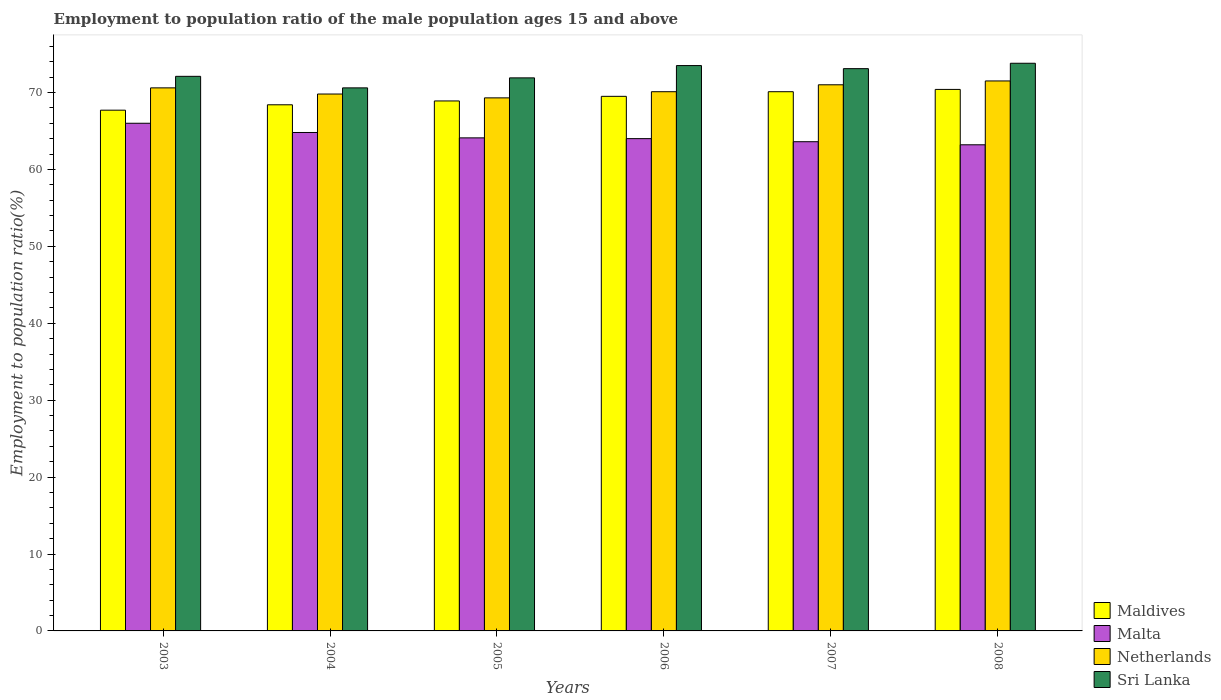How many groups of bars are there?
Your answer should be compact. 6. Are the number of bars on each tick of the X-axis equal?
Your answer should be very brief. Yes. How many bars are there on the 6th tick from the left?
Provide a succinct answer. 4. How many bars are there on the 5th tick from the right?
Offer a terse response. 4. What is the label of the 3rd group of bars from the left?
Offer a very short reply. 2005. In how many cases, is the number of bars for a given year not equal to the number of legend labels?
Make the answer very short. 0. What is the employment to population ratio in Netherlands in 2006?
Provide a succinct answer. 70.1. Across all years, what is the maximum employment to population ratio in Maldives?
Keep it short and to the point. 70.4. Across all years, what is the minimum employment to population ratio in Sri Lanka?
Give a very brief answer. 70.6. What is the total employment to population ratio in Netherlands in the graph?
Provide a short and direct response. 422.3. What is the difference between the employment to population ratio in Sri Lanka in 2003 and that in 2005?
Provide a succinct answer. 0.2. What is the difference between the employment to population ratio in Malta in 2008 and the employment to population ratio in Sri Lanka in 2005?
Your answer should be very brief. -8.7. What is the average employment to population ratio in Malta per year?
Make the answer very short. 64.28. In the year 2008, what is the difference between the employment to population ratio in Malta and employment to population ratio in Maldives?
Provide a succinct answer. -7.2. What is the ratio of the employment to population ratio in Malta in 2003 to that in 2007?
Keep it short and to the point. 1.04. Is the employment to population ratio in Maldives in 2005 less than that in 2006?
Provide a short and direct response. Yes. What is the difference between the highest and the second highest employment to population ratio in Maldives?
Offer a very short reply. 0.3. What is the difference between the highest and the lowest employment to population ratio in Malta?
Give a very brief answer. 2.8. What does the 4th bar from the left in 2003 represents?
Offer a terse response. Sri Lanka. What does the 4th bar from the right in 2007 represents?
Give a very brief answer. Maldives. How many years are there in the graph?
Your response must be concise. 6. Are the values on the major ticks of Y-axis written in scientific E-notation?
Your response must be concise. No. How many legend labels are there?
Keep it short and to the point. 4. How are the legend labels stacked?
Provide a succinct answer. Vertical. What is the title of the graph?
Provide a short and direct response. Employment to population ratio of the male population ages 15 and above. Does "Qatar" appear as one of the legend labels in the graph?
Offer a terse response. No. What is the Employment to population ratio(%) in Maldives in 2003?
Keep it short and to the point. 67.7. What is the Employment to population ratio(%) of Malta in 2003?
Give a very brief answer. 66. What is the Employment to population ratio(%) of Netherlands in 2003?
Ensure brevity in your answer.  70.6. What is the Employment to population ratio(%) in Sri Lanka in 2003?
Give a very brief answer. 72.1. What is the Employment to population ratio(%) of Maldives in 2004?
Provide a short and direct response. 68.4. What is the Employment to population ratio(%) in Malta in 2004?
Provide a short and direct response. 64.8. What is the Employment to population ratio(%) of Netherlands in 2004?
Offer a terse response. 69.8. What is the Employment to population ratio(%) in Sri Lanka in 2004?
Provide a succinct answer. 70.6. What is the Employment to population ratio(%) of Maldives in 2005?
Offer a very short reply. 68.9. What is the Employment to population ratio(%) of Malta in 2005?
Offer a very short reply. 64.1. What is the Employment to population ratio(%) in Netherlands in 2005?
Your response must be concise. 69.3. What is the Employment to population ratio(%) in Sri Lanka in 2005?
Keep it short and to the point. 71.9. What is the Employment to population ratio(%) in Maldives in 2006?
Keep it short and to the point. 69.5. What is the Employment to population ratio(%) in Netherlands in 2006?
Your response must be concise. 70.1. What is the Employment to population ratio(%) in Sri Lanka in 2006?
Keep it short and to the point. 73.5. What is the Employment to population ratio(%) in Maldives in 2007?
Offer a terse response. 70.1. What is the Employment to population ratio(%) in Malta in 2007?
Your response must be concise. 63.6. What is the Employment to population ratio(%) in Netherlands in 2007?
Your response must be concise. 71. What is the Employment to population ratio(%) in Sri Lanka in 2007?
Your answer should be very brief. 73.1. What is the Employment to population ratio(%) of Maldives in 2008?
Give a very brief answer. 70.4. What is the Employment to population ratio(%) in Malta in 2008?
Your answer should be very brief. 63.2. What is the Employment to population ratio(%) of Netherlands in 2008?
Provide a short and direct response. 71.5. What is the Employment to population ratio(%) in Sri Lanka in 2008?
Provide a short and direct response. 73.8. Across all years, what is the maximum Employment to population ratio(%) of Maldives?
Provide a short and direct response. 70.4. Across all years, what is the maximum Employment to population ratio(%) of Netherlands?
Offer a terse response. 71.5. Across all years, what is the maximum Employment to population ratio(%) in Sri Lanka?
Offer a very short reply. 73.8. Across all years, what is the minimum Employment to population ratio(%) of Maldives?
Offer a very short reply. 67.7. Across all years, what is the minimum Employment to population ratio(%) of Malta?
Your answer should be very brief. 63.2. Across all years, what is the minimum Employment to population ratio(%) of Netherlands?
Your answer should be very brief. 69.3. Across all years, what is the minimum Employment to population ratio(%) of Sri Lanka?
Offer a terse response. 70.6. What is the total Employment to population ratio(%) in Maldives in the graph?
Keep it short and to the point. 415. What is the total Employment to population ratio(%) in Malta in the graph?
Offer a terse response. 385.7. What is the total Employment to population ratio(%) in Netherlands in the graph?
Your response must be concise. 422.3. What is the total Employment to population ratio(%) of Sri Lanka in the graph?
Offer a terse response. 435. What is the difference between the Employment to population ratio(%) of Maldives in 2003 and that in 2004?
Your answer should be very brief. -0.7. What is the difference between the Employment to population ratio(%) of Malta in 2003 and that in 2004?
Provide a short and direct response. 1.2. What is the difference between the Employment to population ratio(%) of Netherlands in 2003 and that in 2004?
Offer a terse response. 0.8. What is the difference between the Employment to population ratio(%) in Sri Lanka in 2003 and that in 2004?
Offer a very short reply. 1.5. What is the difference between the Employment to population ratio(%) in Maldives in 2003 and that in 2005?
Your answer should be very brief. -1.2. What is the difference between the Employment to population ratio(%) in Netherlands in 2003 and that in 2005?
Offer a very short reply. 1.3. What is the difference between the Employment to population ratio(%) of Maldives in 2003 and that in 2006?
Offer a terse response. -1.8. What is the difference between the Employment to population ratio(%) of Netherlands in 2003 and that in 2007?
Offer a terse response. -0.4. What is the difference between the Employment to population ratio(%) of Sri Lanka in 2003 and that in 2007?
Give a very brief answer. -1. What is the difference between the Employment to population ratio(%) in Maldives in 2003 and that in 2008?
Offer a terse response. -2.7. What is the difference between the Employment to population ratio(%) in Malta in 2003 and that in 2008?
Make the answer very short. 2.8. What is the difference between the Employment to population ratio(%) of Netherlands in 2003 and that in 2008?
Give a very brief answer. -0.9. What is the difference between the Employment to population ratio(%) in Maldives in 2004 and that in 2005?
Keep it short and to the point. -0.5. What is the difference between the Employment to population ratio(%) in Malta in 2004 and that in 2005?
Offer a terse response. 0.7. What is the difference between the Employment to population ratio(%) in Maldives in 2004 and that in 2007?
Your answer should be compact. -1.7. What is the difference between the Employment to population ratio(%) in Malta in 2004 and that in 2007?
Offer a very short reply. 1.2. What is the difference between the Employment to population ratio(%) in Netherlands in 2004 and that in 2007?
Keep it short and to the point. -1.2. What is the difference between the Employment to population ratio(%) of Maldives in 2004 and that in 2008?
Ensure brevity in your answer.  -2. What is the difference between the Employment to population ratio(%) in Sri Lanka in 2004 and that in 2008?
Offer a terse response. -3.2. What is the difference between the Employment to population ratio(%) in Maldives in 2005 and that in 2006?
Offer a terse response. -0.6. What is the difference between the Employment to population ratio(%) of Netherlands in 2005 and that in 2006?
Give a very brief answer. -0.8. What is the difference between the Employment to population ratio(%) of Sri Lanka in 2005 and that in 2007?
Provide a short and direct response. -1.2. What is the difference between the Employment to population ratio(%) in Maldives in 2005 and that in 2008?
Provide a short and direct response. -1.5. What is the difference between the Employment to population ratio(%) in Malta in 2005 and that in 2008?
Provide a succinct answer. 0.9. What is the difference between the Employment to population ratio(%) in Netherlands in 2005 and that in 2008?
Offer a terse response. -2.2. What is the difference between the Employment to population ratio(%) in Maldives in 2006 and that in 2007?
Provide a short and direct response. -0.6. What is the difference between the Employment to population ratio(%) of Malta in 2006 and that in 2007?
Provide a short and direct response. 0.4. What is the difference between the Employment to population ratio(%) in Netherlands in 2006 and that in 2007?
Give a very brief answer. -0.9. What is the difference between the Employment to population ratio(%) of Malta in 2006 and that in 2008?
Your answer should be very brief. 0.8. What is the difference between the Employment to population ratio(%) in Netherlands in 2006 and that in 2008?
Offer a terse response. -1.4. What is the difference between the Employment to population ratio(%) in Sri Lanka in 2006 and that in 2008?
Make the answer very short. -0.3. What is the difference between the Employment to population ratio(%) in Maldives in 2007 and that in 2008?
Make the answer very short. -0.3. What is the difference between the Employment to population ratio(%) in Malta in 2007 and that in 2008?
Your answer should be very brief. 0.4. What is the difference between the Employment to population ratio(%) of Netherlands in 2007 and that in 2008?
Ensure brevity in your answer.  -0.5. What is the difference between the Employment to population ratio(%) in Maldives in 2003 and the Employment to population ratio(%) in Sri Lanka in 2004?
Your answer should be very brief. -2.9. What is the difference between the Employment to population ratio(%) in Netherlands in 2003 and the Employment to population ratio(%) in Sri Lanka in 2004?
Offer a very short reply. 0. What is the difference between the Employment to population ratio(%) in Maldives in 2003 and the Employment to population ratio(%) in Malta in 2005?
Offer a terse response. 3.6. What is the difference between the Employment to population ratio(%) in Maldives in 2003 and the Employment to population ratio(%) in Sri Lanka in 2005?
Your answer should be very brief. -4.2. What is the difference between the Employment to population ratio(%) in Malta in 2003 and the Employment to population ratio(%) in Netherlands in 2005?
Offer a very short reply. -3.3. What is the difference between the Employment to population ratio(%) in Malta in 2003 and the Employment to population ratio(%) in Sri Lanka in 2005?
Your answer should be very brief. -5.9. What is the difference between the Employment to population ratio(%) of Maldives in 2003 and the Employment to population ratio(%) of Sri Lanka in 2006?
Make the answer very short. -5.8. What is the difference between the Employment to population ratio(%) in Malta in 2003 and the Employment to population ratio(%) in Sri Lanka in 2006?
Keep it short and to the point. -7.5. What is the difference between the Employment to population ratio(%) of Maldives in 2003 and the Employment to population ratio(%) of Netherlands in 2007?
Ensure brevity in your answer.  -3.3. What is the difference between the Employment to population ratio(%) of Maldives in 2003 and the Employment to population ratio(%) of Sri Lanka in 2007?
Keep it short and to the point. -5.4. What is the difference between the Employment to population ratio(%) of Malta in 2003 and the Employment to population ratio(%) of Sri Lanka in 2007?
Make the answer very short. -7.1. What is the difference between the Employment to population ratio(%) of Netherlands in 2003 and the Employment to population ratio(%) of Sri Lanka in 2007?
Make the answer very short. -2.5. What is the difference between the Employment to population ratio(%) of Maldives in 2003 and the Employment to population ratio(%) of Netherlands in 2008?
Your response must be concise. -3.8. What is the difference between the Employment to population ratio(%) in Malta in 2003 and the Employment to population ratio(%) in Sri Lanka in 2008?
Your response must be concise. -7.8. What is the difference between the Employment to population ratio(%) in Maldives in 2004 and the Employment to population ratio(%) in Malta in 2005?
Provide a short and direct response. 4.3. What is the difference between the Employment to population ratio(%) of Maldives in 2004 and the Employment to population ratio(%) of Netherlands in 2005?
Give a very brief answer. -0.9. What is the difference between the Employment to population ratio(%) in Malta in 2004 and the Employment to population ratio(%) in Netherlands in 2005?
Your response must be concise. -4.5. What is the difference between the Employment to population ratio(%) in Maldives in 2004 and the Employment to population ratio(%) in Netherlands in 2006?
Offer a very short reply. -1.7. What is the difference between the Employment to population ratio(%) in Malta in 2004 and the Employment to population ratio(%) in Sri Lanka in 2006?
Your answer should be very brief. -8.7. What is the difference between the Employment to population ratio(%) of Netherlands in 2004 and the Employment to population ratio(%) of Sri Lanka in 2006?
Keep it short and to the point. -3.7. What is the difference between the Employment to population ratio(%) of Maldives in 2004 and the Employment to population ratio(%) of Sri Lanka in 2007?
Offer a very short reply. -4.7. What is the difference between the Employment to population ratio(%) in Netherlands in 2004 and the Employment to population ratio(%) in Sri Lanka in 2007?
Make the answer very short. -3.3. What is the difference between the Employment to population ratio(%) of Maldives in 2004 and the Employment to population ratio(%) of Malta in 2008?
Offer a terse response. 5.2. What is the difference between the Employment to population ratio(%) in Maldives in 2004 and the Employment to population ratio(%) in Netherlands in 2008?
Make the answer very short. -3.1. What is the difference between the Employment to population ratio(%) in Maldives in 2004 and the Employment to population ratio(%) in Sri Lanka in 2008?
Your answer should be compact. -5.4. What is the difference between the Employment to population ratio(%) in Malta in 2004 and the Employment to population ratio(%) in Sri Lanka in 2008?
Make the answer very short. -9. What is the difference between the Employment to population ratio(%) in Maldives in 2005 and the Employment to population ratio(%) in Netherlands in 2006?
Make the answer very short. -1.2. What is the difference between the Employment to population ratio(%) of Malta in 2005 and the Employment to population ratio(%) of Netherlands in 2006?
Your answer should be very brief. -6. What is the difference between the Employment to population ratio(%) of Malta in 2005 and the Employment to population ratio(%) of Sri Lanka in 2007?
Provide a succinct answer. -9. What is the difference between the Employment to population ratio(%) of Netherlands in 2005 and the Employment to population ratio(%) of Sri Lanka in 2007?
Offer a very short reply. -3.8. What is the difference between the Employment to population ratio(%) of Maldives in 2005 and the Employment to population ratio(%) of Malta in 2008?
Provide a short and direct response. 5.7. What is the difference between the Employment to population ratio(%) in Maldives in 2005 and the Employment to population ratio(%) in Netherlands in 2008?
Offer a terse response. -2.6. What is the difference between the Employment to population ratio(%) in Maldives in 2005 and the Employment to population ratio(%) in Sri Lanka in 2008?
Your response must be concise. -4.9. What is the difference between the Employment to population ratio(%) in Malta in 2005 and the Employment to population ratio(%) in Sri Lanka in 2008?
Provide a succinct answer. -9.7. What is the difference between the Employment to population ratio(%) of Maldives in 2006 and the Employment to population ratio(%) of Malta in 2007?
Offer a terse response. 5.9. What is the difference between the Employment to population ratio(%) of Maldives in 2006 and the Employment to population ratio(%) of Netherlands in 2007?
Make the answer very short. -1.5. What is the difference between the Employment to population ratio(%) in Malta in 2006 and the Employment to population ratio(%) in Sri Lanka in 2007?
Make the answer very short. -9.1. What is the difference between the Employment to population ratio(%) of Malta in 2006 and the Employment to population ratio(%) of Sri Lanka in 2008?
Your answer should be very brief. -9.8. What is the average Employment to population ratio(%) of Maldives per year?
Provide a short and direct response. 69.17. What is the average Employment to population ratio(%) of Malta per year?
Give a very brief answer. 64.28. What is the average Employment to population ratio(%) in Netherlands per year?
Ensure brevity in your answer.  70.38. What is the average Employment to population ratio(%) in Sri Lanka per year?
Your response must be concise. 72.5. In the year 2003, what is the difference between the Employment to population ratio(%) in Malta and Employment to population ratio(%) in Sri Lanka?
Your response must be concise. -6.1. In the year 2004, what is the difference between the Employment to population ratio(%) in Maldives and Employment to population ratio(%) in Netherlands?
Your answer should be compact. -1.4. In the year 2004, what is the difference between the Employment to population ratio(%) in Malta and Employment to population ratio(%) in Sri Lanka?
Provide a succinct answer. -5.8. In the year 2004, what is the difference between the Employment to population ratio(%) of Netherlands and Employment to population ratio(%) of Sri Lanka?
Ensure brevity in your answer.  -0.8. In the year 2005, what is the difference between the Employment to population ratio(%) in Maldives and Employment to population ratio(%) in Netherlands?
Ensure brevity in your answer.  -0.4. In the year 2005, what is the difference between the Employment to population ratio(%) in Maldives and Employment to population ratio(%) in Sri Lanka?
Provide a succinct answer. -3. In the year 2005, what is the difference between the Employment to population ratio(%) in Malta and Employment to population ratio(%) in Sri Lanka?
Offer a very short reply. -7.8. In the year 2005, what is the difference between the Employment to population ratio(%) in Netherlands and Employment to population ratio(%) in Sri Lanka?
Ensure brevity in your answer.  -2.6. In the year 2006, what is the difference between the Employment to population ratio(%) in Maldives and Employment to population ratio(%) in Malta?
Your answer should be very brief. 5.5. In the year 2006, what is the difference between the Employment to population ratio(%) of Maldives and Employment to population ratio(%) of Netherlands?
Give a very brief answer. -0.6. In the year 2006, what is the difference between the Employment to population ratio(%) of Malta and Employment to population ratio(%) of Netherlands?
Offer a very short reply. -6.1. In the year 2007, what is the difference between the Employment to population ratio(%) of Maldives and Employment to population ratio(%) of Netherlands?
Offer a terse response. -0.9. In the year 2007, what is the difference between the Employment to population ratio(%) of Maldives and Employment to population ratio(%) of Sri Lanka?
Keep it short and to the point. -3. In the year 2007, what is the difference between the Employment to population ratio(%) of Malta and Employment to population ratio(%) of Netherlands?
Your answer should be compact. -7.4. In the year 2007, what is the difference between the Employment to population ratio(%) of Malta and Employment to population ratio(%) of Sri Lanka?
Ensure brevity in your answer.  -9.5. In the year 2008, what is the difference between the Employment to population ratio(%) of Maldives and Employment to population ratio(%) of Malta?
Your response must be concise. 7.2. In the year 2008, what is the difference between the Employment to population ratio(%) of Malta and Employment to population ratio(%) of Netherlands?
Provide a succinct answer. -8.3. What is the ratio of the Employment to population ratio(%) in Malta in 2003 to that in 2004?
Your answer should be compact. 1.02. What is the ratio of the Employment to population ratio(%) in Netherlands in 2003 to that in 2004?
Provide a short and direct response. 1.01. What is the ratio of the Employment to population ratio(%) of Sri Lanka in 2003 to that in 2004?
Offer a very short reply. 1.02. What is the ratio of the Employment to population ratio(%) in Maldives in 2003 to that in 2005?
Your answer should be very brief. 0.98. What is the ratio of the Employment to population ratio(%) of Malta in 2003 to that in 2005?
Make the answer very short. 1.03. What is the ratio of the Employment to population ratio(%) in Netherlands in 2003 to that in 2005?
Provide a succinct answer. 1.02. What is the ratio of the Employment to population ratio(%) of Sri Lanka in 2003 to that in 2005?
Keep it short and to the point. 1. What is the ratio of the Employment to population ratio(%) of Maldives in 2003 to that in 2006?
Your answer should be compact. 0.97. What is the ratio of the Employment to population ratio(%) of Malta in 2003 to that in 2006?
Offer a terse response. 1.03. What is the ratio of the Employment to population ratio(%) of Netherlands in 2003 to that in 2006?
Offer a terse response. 1.01. What is the ratio of the Employment to population ratio(%) of Sri Lanka in 2003 to that in 2006?
Your response must be concise. 0.98. What is the ratio of the Employment to population ratio(%) in Maldives in 2003 to that in 2007?
Provide a succinct answer. 0.97. What is the ratio of the Employment to population ratio(%) of Malta in 2003 to that in 2007?
Offer a terse response. 1.04. What is the ratio of the Employment to population ratio(%) in Netherlands in 2003 to that in 2007?
Your response must be concise. 0.99. What is the ratio of the Employment to population ratio(%) of Sri Lanka in 2003 to that in 2007?
Give a very brief answer. 0.99. What is the ratio of the Employment to population ratio(%) in Maldives in 2003 to that in 2008?
Keep it short and to the point. 0.96. What is the ratio of the Employment to population ratio(%) in Malta in 2003 to that in 2008?
Your response must be concise. 1.04. What is the ratio of the Employment to population ratio(%) of Netherlands in 2003 to that in 2008?
Offer a very short reply. 0.99. What is the ratio of the Employment to population ratio(%) in Sri Lanka in 2003 to that in 2008?
Keep it short and to the point. 0.98. What is the ratio of the Employment to population ratio(%) in Malta in 2004 to that in 2005?
Your answer should be very brief. 1.01. What is the ratio of the Employment to population ratio(%) of Netherlands in 2004 to that in 2005?
Offer a terse response. 1.01. What is the ratio of the Employment to population ratio(%) of Sri Lanka in 2004 to that in 2005?
Your response must be concise. 0.98. What is the ratio of the Employment to population ratio(%) in Maldives in 2004 to that in 2006?
Make the answer very short. 0.98. What is the ratio of the Employment to population ratio(%) of Malta in 2004 to that in 2006?
Make the answer very short. 1.01. What is the ratio of the Employment to population ratio(%) of Netherlands in 2004 to that in 2006?
Your answer should be very brief. 1. What is the ratio of the Employment to population ratio(%) of Sri Lanka in 2004 to that in 2006?
Provide a succinct answer. 0.96. What is the ratio of the Employment to population ratio(%) in Maldives in 2004 to that in 2007?
Give a very brief answer. 0.98. What is the ratio of the Employment to population ratio(%) in Malta in 2004 to that in 2007?
Offer a terse response. 1.02. What is the ratio of the Employment to population ratio(%) in Netherlands in 2004 to that in 2007?
Provide a succinct answer. 0.98. What is the ratio of the Employment to population ratio(%) in Sri Lanka in 2004 to that in 2007?
Your answer should be compact. 0.97. What is the ratio of the Employment to population ratio(%) of Maldives in 2004 to that in 2008?
Give a very brief answer. 0.97. What is the ratio of the Employment to population ratio(%) in Malta in 2004 to that in 2008?
Give a very brief answer. 1.03. What is the ratio of the Employment to population ratio(%) of Netherlands in 2004 to that in 2008?
Provide a short and direct response. 0.98. What is the ratio of the Employment to population ratio(%) of Sri Lanka in 2004 to that in 2008?
Offer a terse response. 0.96. What is the ratio of the Employment to population ratio(%) in Malta in 2005 to that in 2006?
Offer a terse response. 1. What is the ratio of the Employment to population ratio(%) in Sri Lanka in 2005 to that in 2006?
Your answer should be compact. 0.98. What is the ratio of the Employment to population ratio(%) in Maldives in 2005 to that in 2007?
Your response must be concise. 0.98. What is the ratio of the Employment to population ratio(%) in Malta in 2005 to that in 2007?
Offer a terse response. 1.01. What is the ratio of the Employment to population ratio(%) of Netherlands in 2005 to that in 2007?
Offer a terse response. 0.98. What is the ratio of the Employment to population ratio(%) of Sri Lanka in 2005 to that in 2007?
Keep it short and to the point. 0.98. What is the ratio of the Employment to population ratio(%) of Maldives in 2005 to that in 2008?
Your answer should be very brief. 0.98. What is the ratio of the Employment to population ratio(%) of Malta in 2005 to that in 2008?
Offer a terse response. 1.01. What is the ratio of the Employment to population ratio(%) of Netherlands in 2005 to that in 2008?
Your answer should be very brief. 0.97. What is the ratio of the Employment to population ratio(%) of Sri Lanka in 2005 to that in 2008?
Offer a terse response. 0.97. What is the ratio of the Employment to population ratio(%) in Maldives in 2006 to that in 2007?
Offer a terse response. 0.99. What is the ratio of the Employment to population ratio(%) in Malta in 2006 to that in 2007?
Ensure brevity in your answer.  1.01. What is the ratio of the Employment to population ratio(%) in Netherlands in 2006 to that in 2007?
Offer a terse response. 0.99. What is the ratio of the Employment to population ratio(%) of Sri Lanka in 2006 to that in 2007?
Keep it short and to the point. 1.01. What is the ratio of the Employment to population ratio(%) in Maldives in 2006 to that in 2008?
Make the answer very short. 0.99. What is the ratio of the Employment to population ratio(%) in Malta in 2006 to that in 2008?
Make the answer very short. 1.01. What is the ratio of the Employment to population ratio(%) of Netherlands in 2006 to that in 2008?
Make the answer very short. 0.98. What is the ratio of the Employment to population ratio(%) in Sri Lanka in 2007 to that in 2008?
Offer a very short reply. 0.99. What is the difference between the highest and the second highest Employment to population ratio(%) in Maldives?
Keep it short and to the point. 0.3. What is the difference between the highest and the second highest Employment to population ratio(%) in Netherlands?
Offer a terse response. 0.5. 